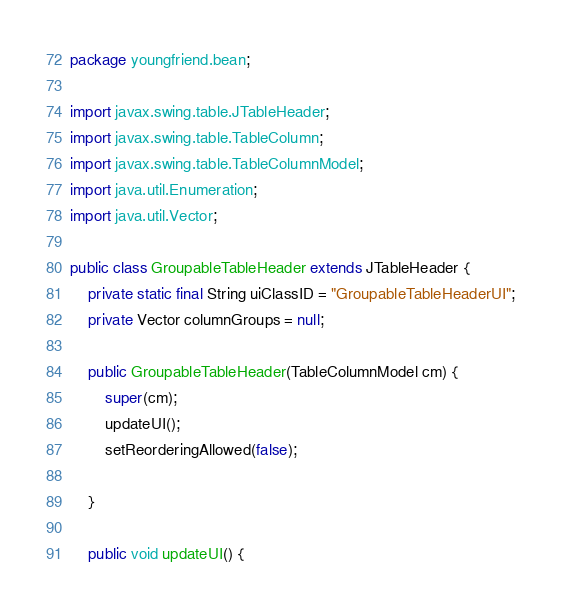Convert code to text. <code><loc_0><loc_0><loc_500><loc_500><_Java_>package youngfriend.bean;

import javax.swing.table.JTableHeader;
import javax.swing.table.TableColumn;
import javax.swing.table.TableColumnModel;
import java.util.Enumeration;
import java.util.Vector;

public class GroupableTableHeader extends JTableHeader {
    private static final String uiClassID = "GroupableTableHeaderUI";
    private Vector columnGroups = null;

    public GroupableTableHeader(TableColumnModel cm) {
        super(cm);
        updateUI();
        setReorderingAllowed(false);

    }

    public void updateUI() {</code> 